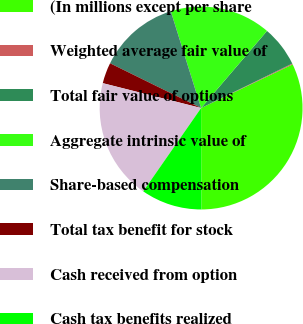Convert chart to OTSL. <chart><loc_0><loc_0><loc_500><loc_500><pie_chart><fcel>(In millions except per share<fcel>Weighted average fair value of<fcel>Total fair value of options<fcel>Aggregate intrinsic value of<fcel>Share-based compensation<fcel>Total tax benefit for stock<fcel>Cash received from option<fcel>Cash tax benefits realized<nl><fcel>32.04%<fcel>0.14%<fcel>6.52%<fcel>16.09%<fcel>12.9%<fcel>3.33%<fcel>19.28%<fcel>9.71%<nl></chart> 